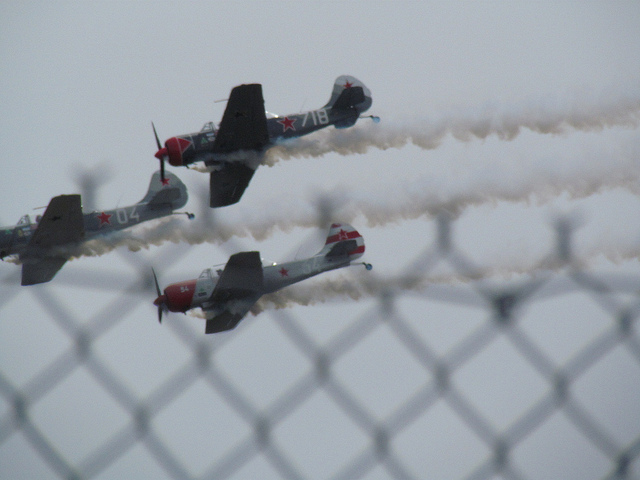What colors can be seen on the airplanes? The airplanes display a combination of red, white, and gray colors, with distinct markings and numbers enhancing their visual identification. 